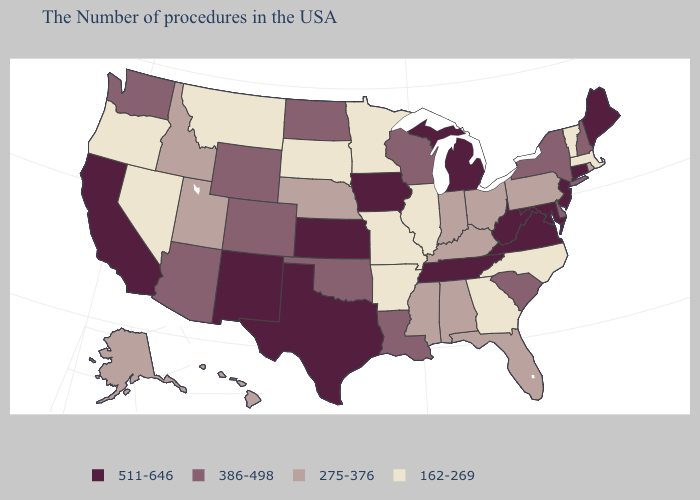What is the highest value in the Northeast ?
Write a very short answer. 511-646. Name the states that have a value in the range 162-269?
Keep it brief. Massachusetts, Vermont, North Carolina, Georgia, Illinois, Missouri, Arkansas, Minnesota, South Dakota, Montana, Nevada, Oregon. What is the lowest value in states that border Connecticut?
Answer briefly. 162-269. Does the first symbol in the legend represent the smallest category?
Be succinct. No. What is the lowest value in the USA?
Keep it brief. 162-269. Name the states that have a value in the range 162-269?
Give a very brief answer. Massachusetts, Vermont, North Carolina, Georgia, Illinois, Missouri, Arkansas, Minnesota, South Dakota, Montana, Nevada, Oregon. Does Vermont have the highest value in the Northeast?
Short answer required. No. Which states have the lowest value in the Northeast?
Be succinct. Massachusetts, Vermont. Name the states that have a value in the range 275-376?
Quick response, please. Rhode Island, Pennsylvania, Ohio, Florida, Kentucky, Indiana, Alabama, Mississippi, Nebraska, Utah, Idaho, Alaska, Hawaii. Name the states that have a value in the range 511-646?
Concise answer only. Maine, Connecticut, New Jersey, Maryland, Virginia, West Virginia, Michigan, Tennessee, Iowa, Kansas, Texas, New Mexico, California. What is the value of New York?
Write a very short answer. 386-498. Does North Dakota have the lowest value in the MidWest?
Be succinct. No. Name the states that have a value in the range 386-498?
Be succinct. New Hampshire, New York, Delaware, South Carolina, Wisconsin, Louisiana, Oklahoma, North Dakota, Wyoming, Colorado, Arizona, Washington. Does Ohio have the same value as Mississippi?
Concise answer only. Yes. Is the legend a continuous bar?
Keep it brief. No. 